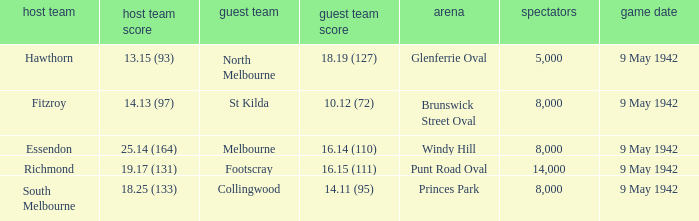How many people attended the game with the home team scoring 18.25 (133)? 1.0. 